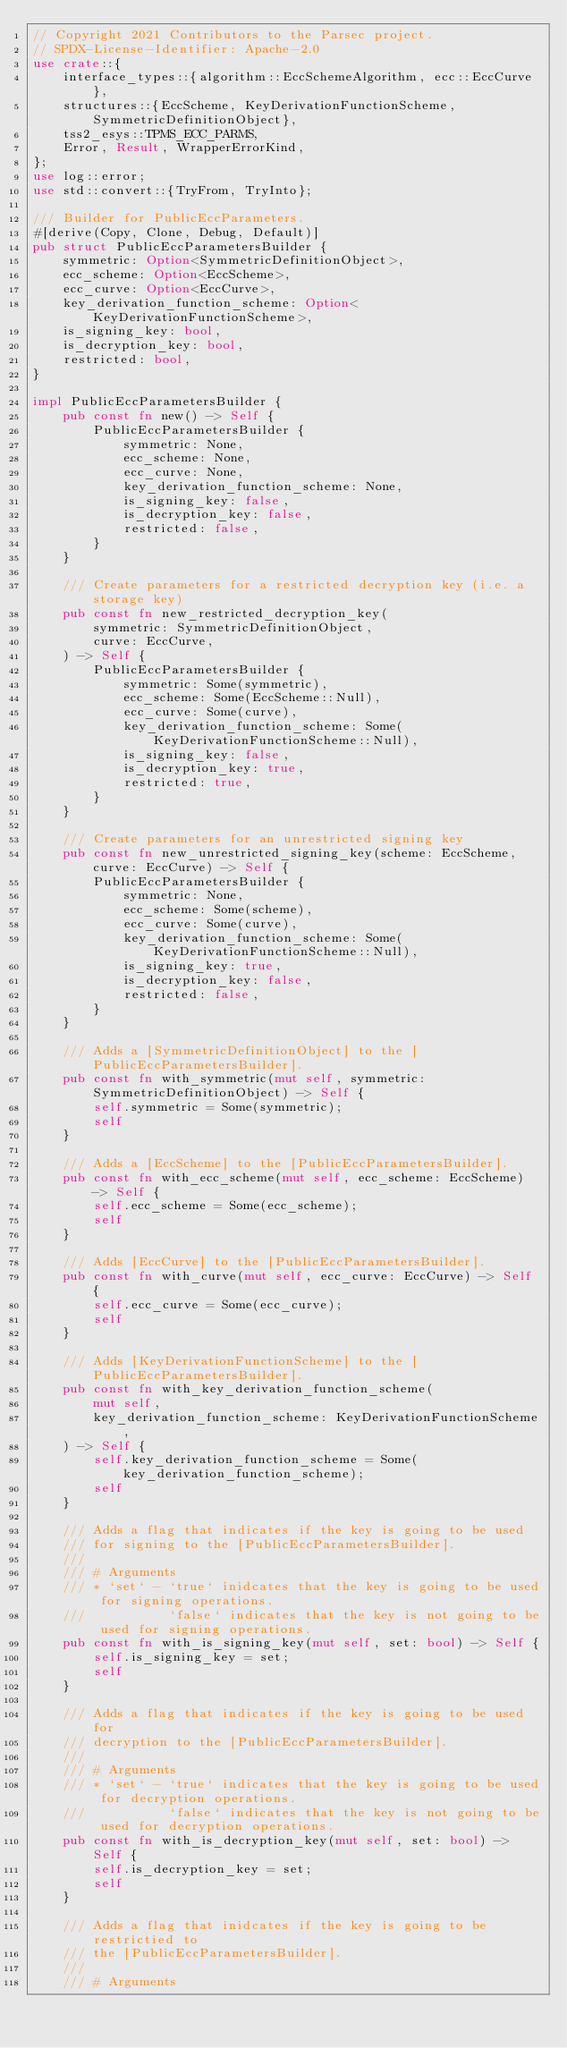Convert code to text. <code><loc_0><loc_0><loc_500><loc_500><_Rust_>// Copyright 2021 Contributors to the Parsec project.
// SPDX-License-Identifier: Apache-2.0
use crate::{
    interface_types::{algorithm::EccSchemeAlgorithm, ecc::EccCurve},
    structures::{EccScheme, KeyDerivationFunctionScheme, SymmetricDefinitionObject},
    tss2_esys::TPMS_ECC_PARMS,
    Error, Result, WrapperErrorKind,
};
use log::error;
use std::convert::{TryFrom, TryInto};

/// Builder for PublicEccParameters.
#[derive(Copy, Clone, Debug, Default)]
pub struct PublicEccParametersBuilder {
    symmetric: Option<SymmetricDefinitionObject>,
    ecc_scheme: Option<EccScheme>,
    ecc_curve: Option<EccCurve>,
    key_derivation_function_scheme: Option<KeyDerivationFunctionScheme>,
    is_signing_key: bool,
    is_decryption_key: bool,
    restricted: bool,
}

impl PublicEccParametersBuilder {
    pub const fn new() -> Self {
        PublicEccParametersBuilder {
            symmetric: None,
            ecc_scheme: None,
            ecc_curve: None,
            key_derivation_function_scheme: None,
            is_signing_key: false,
            is_decryption_key: false,
            restricted: false,
        }
    }

    /// Create parameters for a restricted decryption key (i.e. a storage key)
    pub const fn new_restricted_decryption_key(
        symmetric: SymmetricDefinitionObject,
        curve: EccCurve,
    ) -> Self {
        PublicEccParametersBuilder {
            symmetric: Some(symmetric),
            ecc_scheme: Some(EccScheme::Null),
            ecc_curve: Some(curve),
            key_derivation_function_scheme: Some(KeyDerivationFunctionScheme::Null),
            is_signing_key: false,
            is_decryption_key: true,
            restricted: true,
        }
    }

    /// Create parameters for an unrestricted signing key
    pub const fn new_unrestricted_signing_key(scheme: EccScheme, curve: EccCurve) -> Self {
        PublicEccParametersBuilder {
            symmetric: None,
            ecc_scheme: Some(scheme),
            ecc_curve: Some(curve),
            key_derivation_function_scheme: Some(KeyDerivationFunctionScheme::Null),
            is_signing_key: true,
            is_decryption_key: false,
            restricted: false,
        }
    }

    /// Adds a [SymmetricDefinitionObject] to the [PublicEccParametersBuilder].
    pub const fn with_symmetric(mut self, symmetric: SymmetricDefinitionObject) -> Self {
        self.symmetric = Some(symmetric);
        self
    }

    /// Adds a [EccScheme] to the [PublicEccParametersBuilder].
    pub const fn with_ecc_scheme(mut self, ecc_scheme: EccScheme) -> Self {
        self.ecc_scheme = Some(ecc_scheme);
        self
    }

    /// Adds [EccCurve] to the [PublicEccParametersBuilder].
    pub const fn with_curve(mut self, ecc_curve: EccCurve) -> Self {
        self.ecc_curve = Some(ecc_curve);
        self
    }

    /// Adds [KeyDerivationFunctionScheme] to the [PublicEccParametersBuilder].
    pub const fn with_key_derivation_function_scheme(
        mut self,
        key_derivation_function_scheme: KeyDerivationFunctionScheme,
    ) -> Self {
        self.key_derivation_function_scheme = Some(key_derivation_function_scheme);
        self
    }

    /// Adds a flag that indicates if the key is going to be used
    /// for signing to the [PublicEccParametersBuilder].
    ///
    /// # Arguments
    /// * `set` - `true` inidcates that the key is going to be used for signing operations.
    ///           `false` indicates that the key is not going to be used for signing operations.
    pub const fn with_is_signing_key(mut self, set: bool) -> Self {
        self.is_signing_key = set;
        self
    }

    /// Adds a flag that indicates if the key is going to be used for
    /// decryption to the [PublicEccParametersBuilder].
    ///
    /// # Arguments
    /// * `set` - `true` indicates that the key is going to be used for decryption operations.
    ///           `false` indicates that the key is not going to be used for decryption operations.
    pub const fn with_is_decryption_key(mut self, set: bool) -> Self {
        self.is_decryption_key = set;
        self
    }

    /// Adds a flag that inidcates if the key is going to be restrictied to
    /// the [PublicEccParametersBuilder].
    ///
    /// # Arguments</code> 